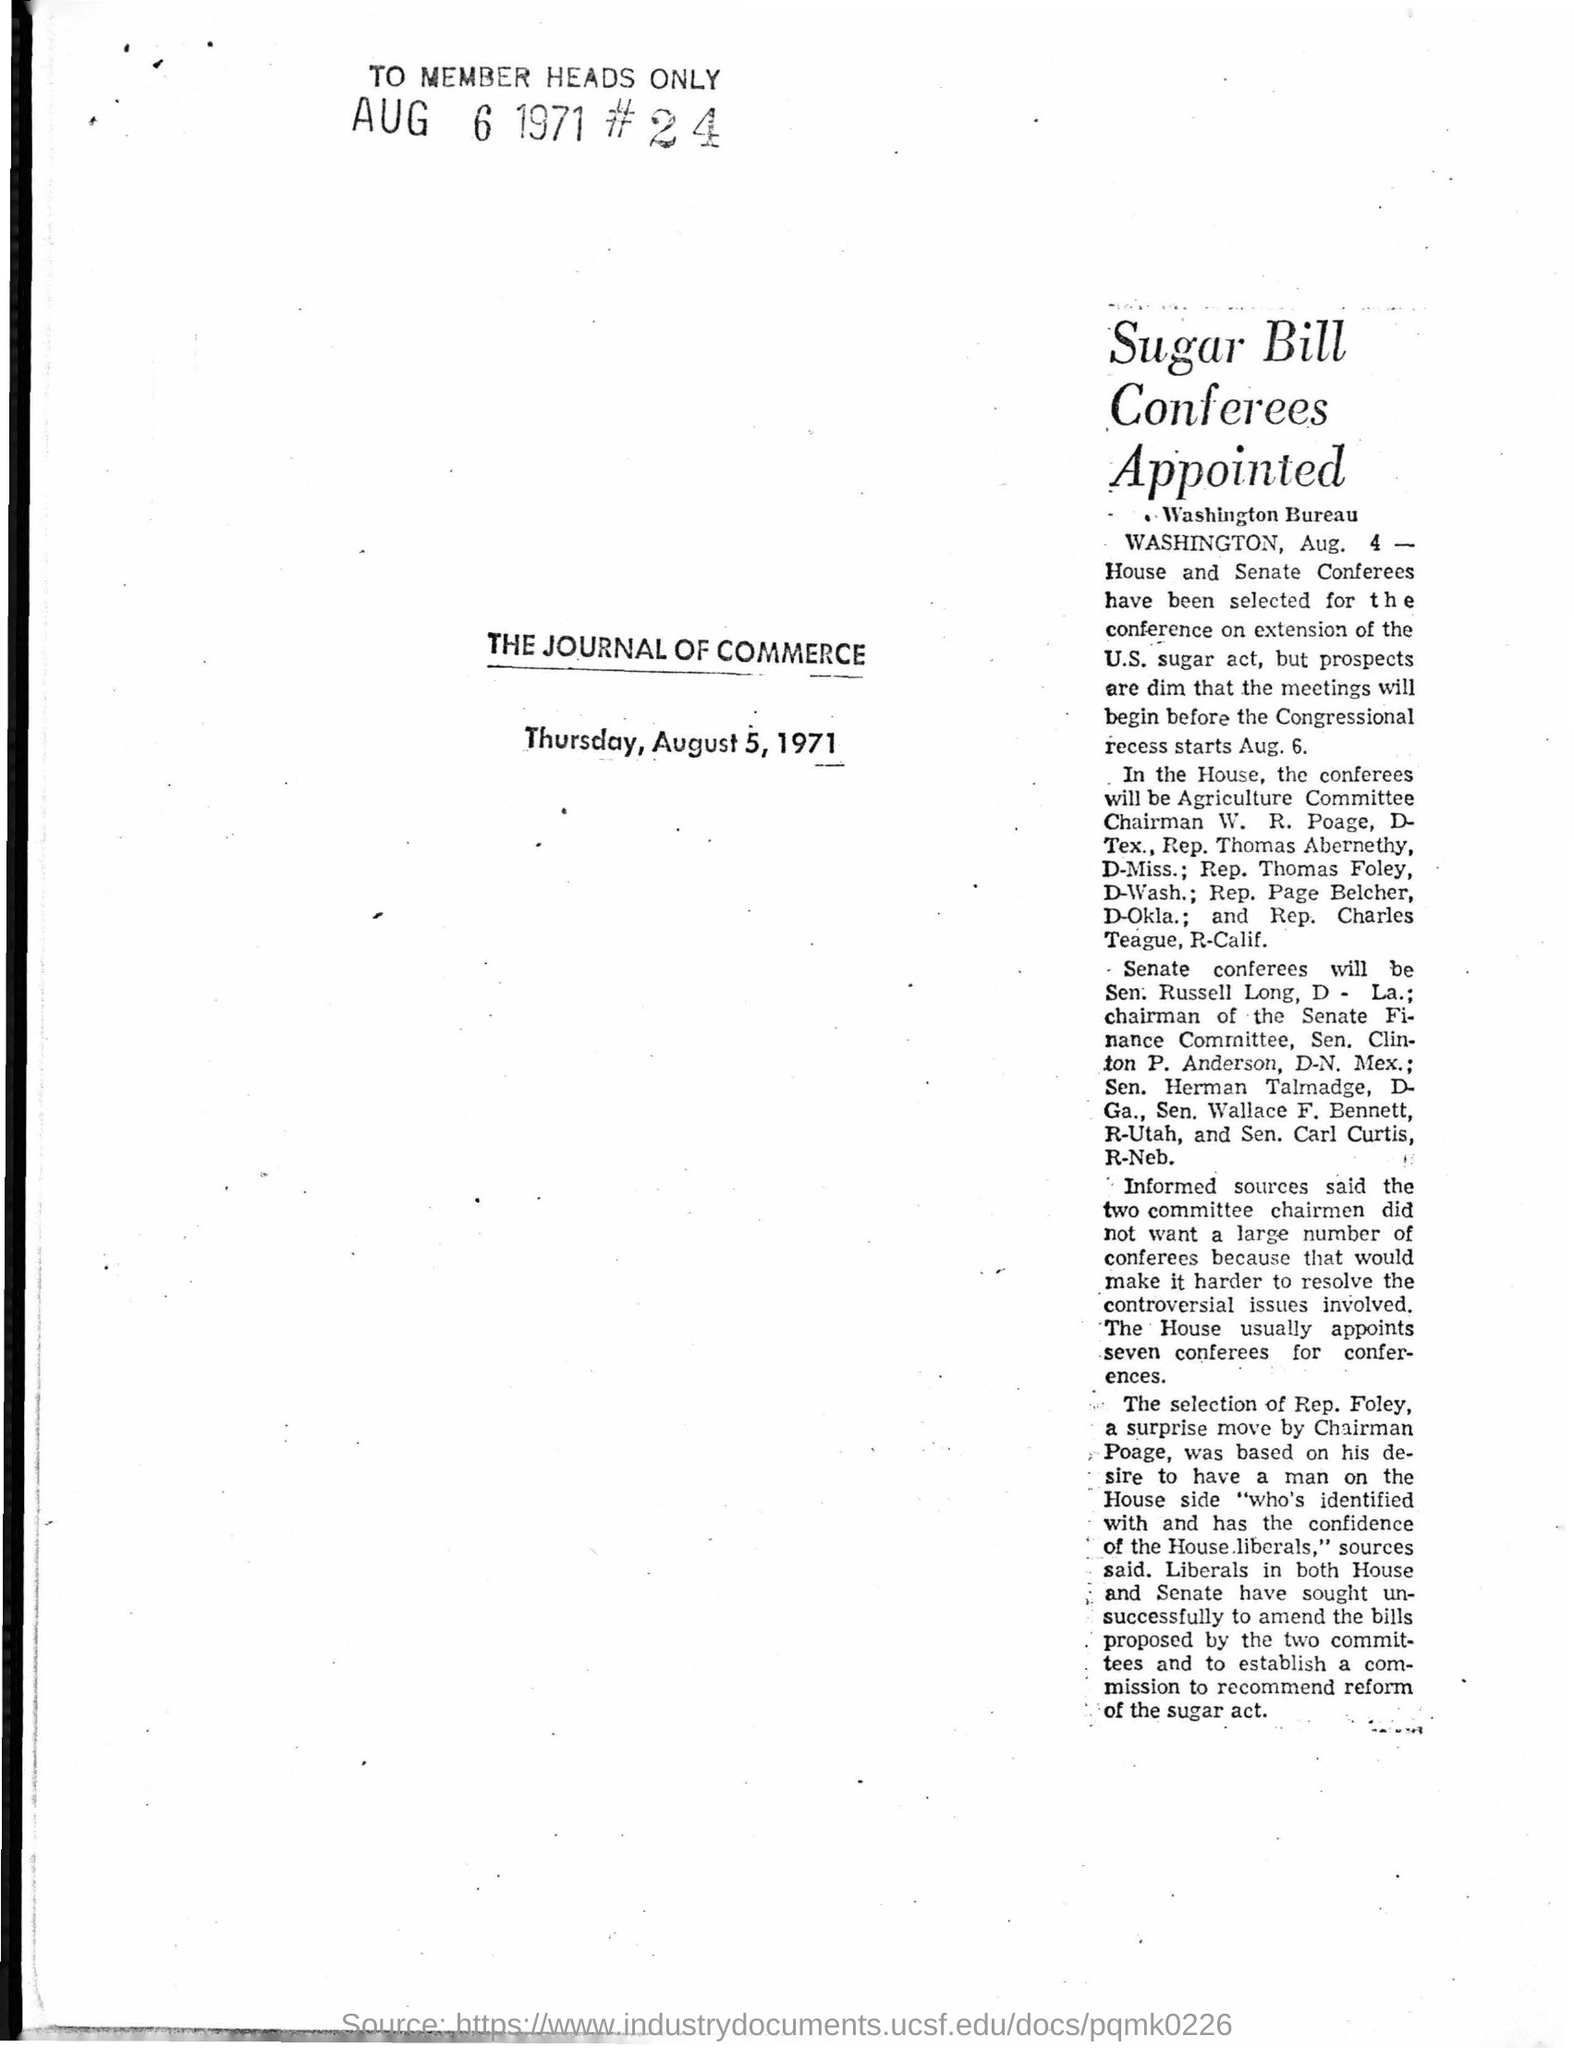Specify some key components in this picture. The article was printed on Thursday, August 5, 1971. 